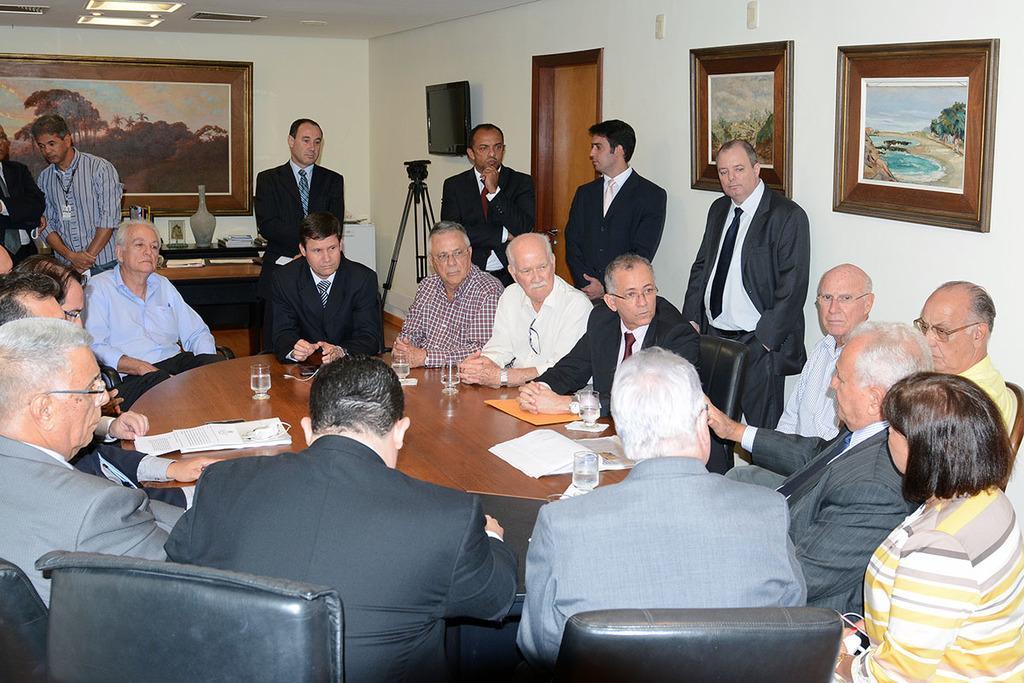Describe this image in one or two sentences. This is a picture taken in a room, there are a group of people sitting on a chair in front of the people there is a wooden table on table there is a paper, file and glasses. Background of this people is a white wall with photo frames and tripod stand, television. 